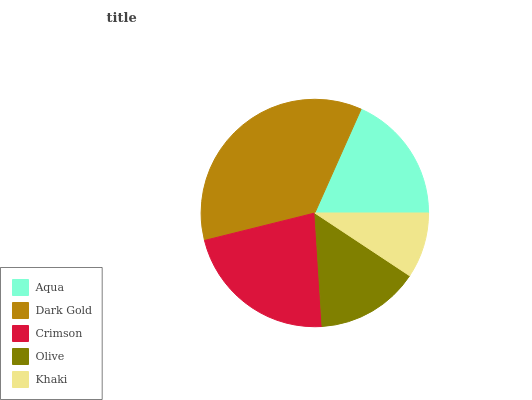Is Khaki the minimum?
Answer yes or no. Yes. Is Dark Gold the maximum?
Answer yes or no. Yes. Is Crimson the minimum?
Answer yes or no. No. Is Crimson the maximum?
Answer yes or no. No. Is Dark Gold greater than Crimson?
Answer yes or no. Yes. Is Crimson less than Dark Gold?
Answer yes or no. Yes. Is Crimson greater than Dark Gold?
Answer yes or no. No. Is Dark Gold less than Crimson?
Answer yes or no. No. Is Aqua the high median?
Answer yes or no. Yes. Is Aqua the low median?
Answer yes or no. Yes. Is Khaki the high median?
Answer yes or no. No. Is Crimson the low median?
Answer yes or no. No. 